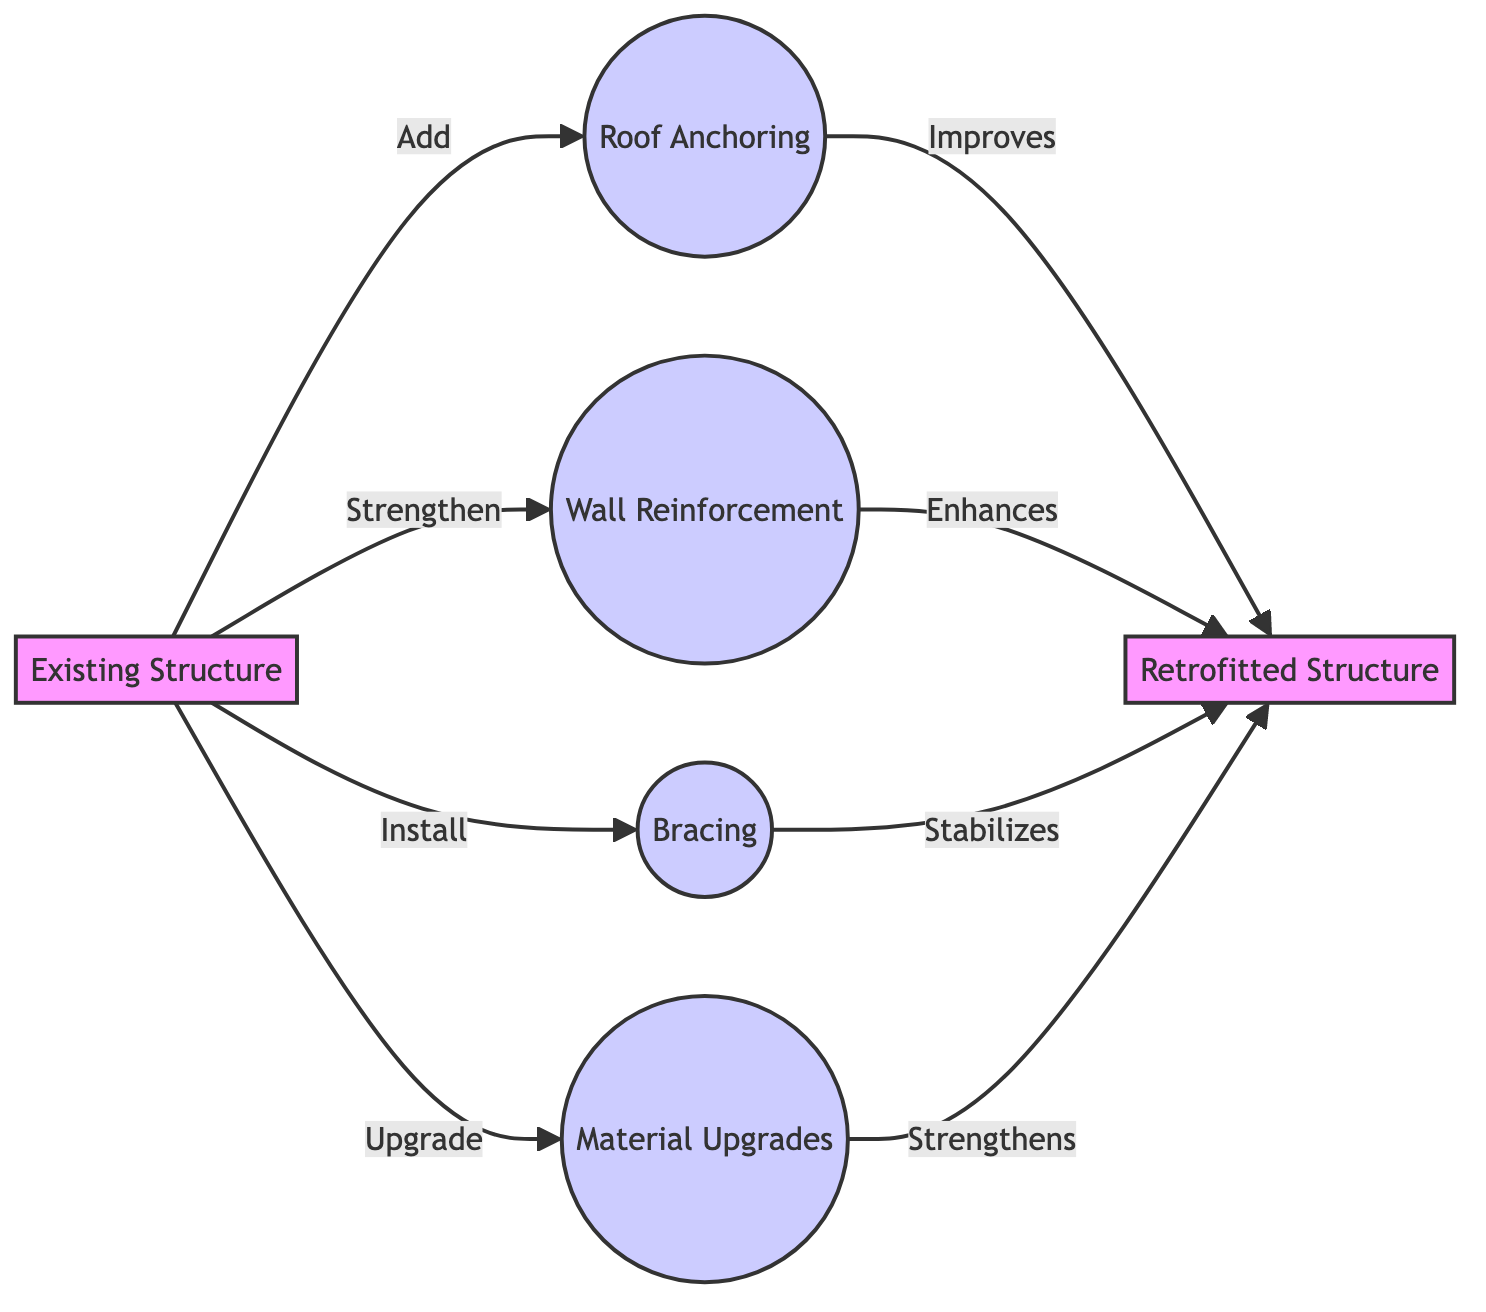What is the starting point of the modifications? The starting point is represented by the node labeled "Existing Structure" indicating where the retrofitting process begins.
Answer: Existing Structure How many types of modifications are shown in the diagram? The diagram includes four distinct types of modifications: roof anchoring, wall reinforcement, bracing, and material upgrades. This is counted from the individual nodes branching from the existing structure.
Answer: Four What is the relationship between roof anchoring and the retrofitted structure? The diagram arrows indicate that roof anchoring "Improves" the retrofitted structure, highlighting the positive impact of this modification on the overall stability and integrity of the building.
Answer: Improves Which modification is labeled as "Stabilizes"? The diagram shows that the modification labeled "Bracing" is described as "Stabilizes" in its relationship to the retrofitted structure, conveying its role in enhancing structural stability.
Answer: Bracing What is the final outcome of the retrofitting process? The outcome of the retrofitting process is depicted as the node labeled "Retrofitted Structure," indicating that the existing structure has been transformed and upgraded through the specified modifications.
Answer: Retrofitted Structure Which modification is associated with strengthening the walls? The modification specifically aimed at wall reinforcement is labeled "Wall Reinforcement," indicating that this action is intended to enhance the strength of the building's walls against hurricane forces.
Answer: Wall Reinforcement 